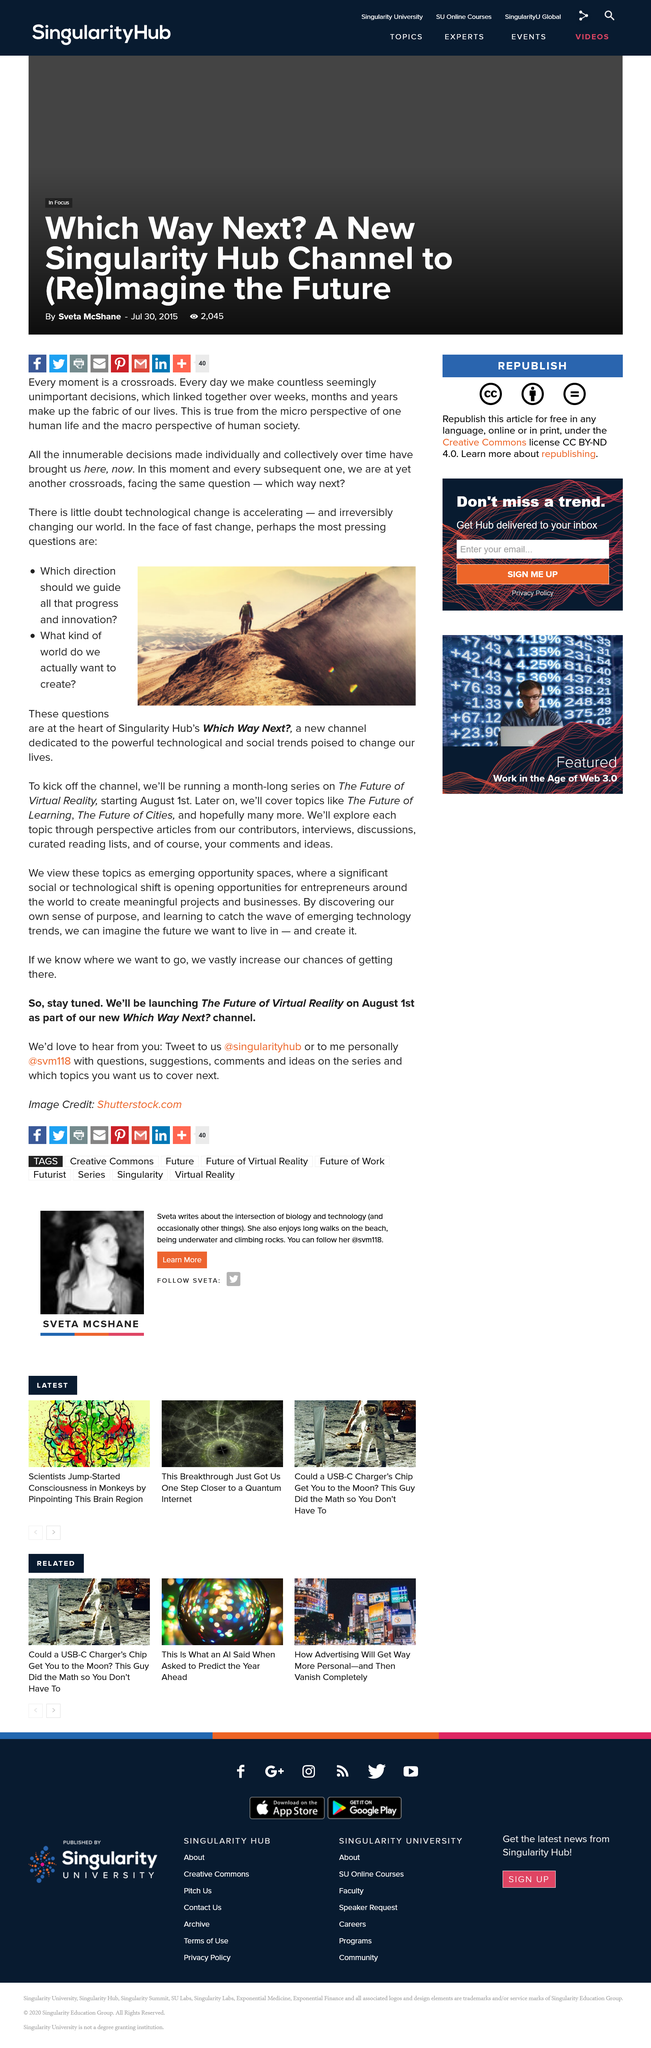Outline some significant characteristics in this image. The image depicts a person climbing up a mountain. Technology is rapidly advancing and continuing to accelerate. The article has two questions. 